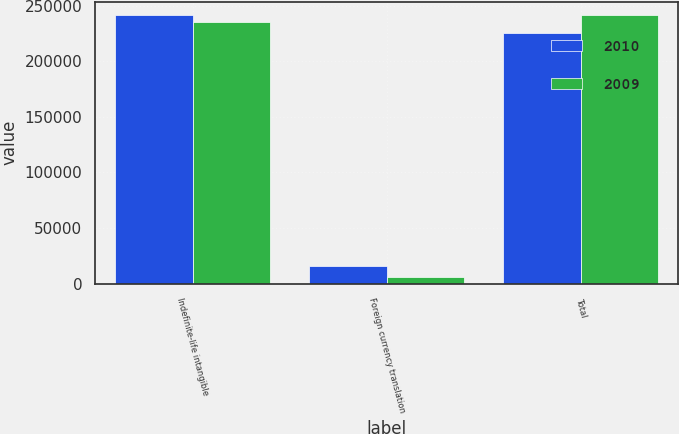<chart> <loc_0><loc_0><loc_500><loc_500><stacked_bar_chart><ecel><fcel>Indefinite-life intangible<fcel>Foreign currency translation<fcel>Total<nl><fcel>2010<fcel>241563<fcel>15884<fcel>225679<nl><fcel>2009<fcel>235610<fcel>5953<fcel>241563<nl></chart> 